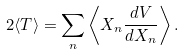Convert formula to latex. <formula><loc_0><loc_0><loc_500><loc_500>2 \langle T \rangle = \sum _ { n } \left \langle X _ { n } { \frac { d V } { d X _ { n } } } \right \rangle .</formula> 